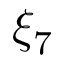Convert formula to latex. <formula><loc_0><loc_0><loc_500><loc_500>\xi _ { 7 }</formula> 